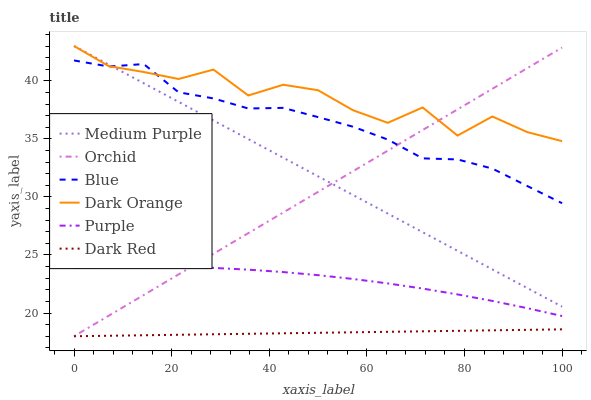Does Dark Red have the minimum area under the curve?
Answer yes or no. Yes. Does Dark Orange have the maximum area under the curve?
Answer yes or no. Yes. Does Purple have the minimum area under the curve?
Answer yes or no. No. Does Purple have the maximum area under the curve?
Answer yes or no. No. Is Dark Red the smoothest?
Answer yes or no. Yes. Is Dark Orange the roughest?
Answer yes or no. Yes. Is Purple the smoothest?
Answer yes or no. No. Is Purple the roughest?
Answer yes or no. No. Does Dark Red have the lowest value?
Answer yes or no. Yes. Does Purple have the lowest value?
Answer yes or no. No. Does Medium Purple have the highest value?
Answer yes or no. Yes. Does Purple have the highest value?
Answer yes or no. No. Is Purple less than Dark Orange?
Answer yes or no. Yes. Is Dark Orange greater than Purple?
Answer yes or no. Yes. Does Blue intersect Dark Orange?
Answer yes or no. Yes. Is Blue less than Dark Orange?
Answer yes or no. No. Is Blue greater than Dark Orange?
Answer yes or no. No. Does Purple intersect Dark Orange?
Answer yes or no. No. 